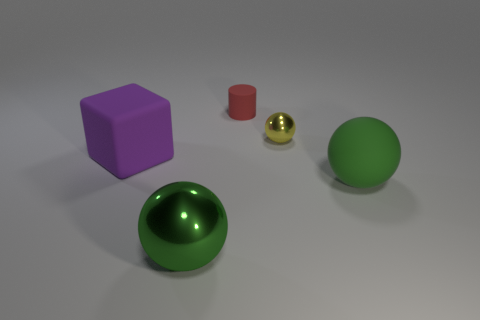How many matte cylinders are in front of the big rubber thing to the left of the rubber thing that is in front of the big purple object?
Provide a short and direct response. 0. There is a thing that is both in front of the tiny cylinder and behind the big purple matte block; what is its shape?
Ensure brevity in your answer.  Sphere. Are there fewer big rubber things that are on the right side of the large green rubber sphere than green shiny spheres?
Your response must be concise. Yes. How many tiny things are either green cylinders or purple rubber objects?
Give a very brief answer. 0. The cylinder has what size?
Your response must be concise. Small. Is there anything else that has the same material as the red object?
Offer a terse response. Yes. There is a matte cylinder; how many small yellow objects are behind it?
Keep it short and to the point. 0. The rubber thing that is the same shape as the large green metal object is what size?
Your answer should be very brief. Large. How big is the thing that is both behind the big purple cube and on the right side of the small rubber object?
Keep it short and to the point. Small. There is a tiny metallic sphere; is its color the same as the shiny sphere that is to the left of the tiny red thing?
Your response must be concise. No. 